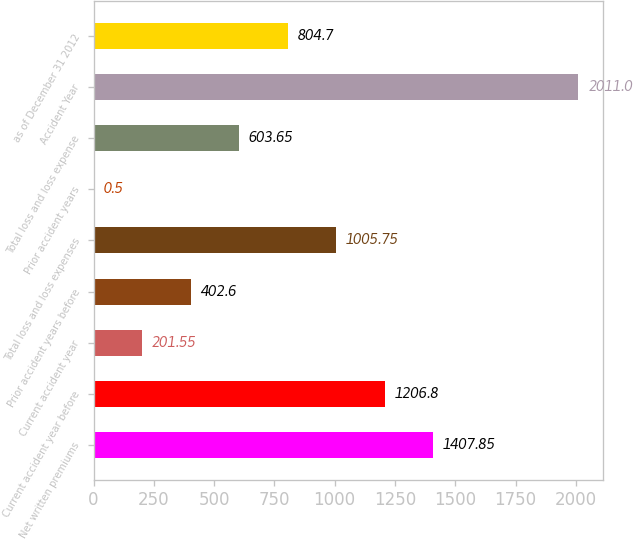<chart> <loc_0><loc_0><loc_500><loc_500><bar_chart><fcel>Net written premiums<fcel>Current accident year before<fcel>Current accident year<fcel>Prior accident years before<fcel>Total loss and loss expenses<fcel>Prior accident years<fcel>Total loss and loss expense<fcel>Accident Year<fcel>as of December 31 2012<nl><fcel>1407.85<fcel>1206.8<fcel>201.55<fcel>402.6<fcel>1005.75<fcel>0.5<fcel>603.65<fcel>2011<fcel>804.7<nl></chart> 